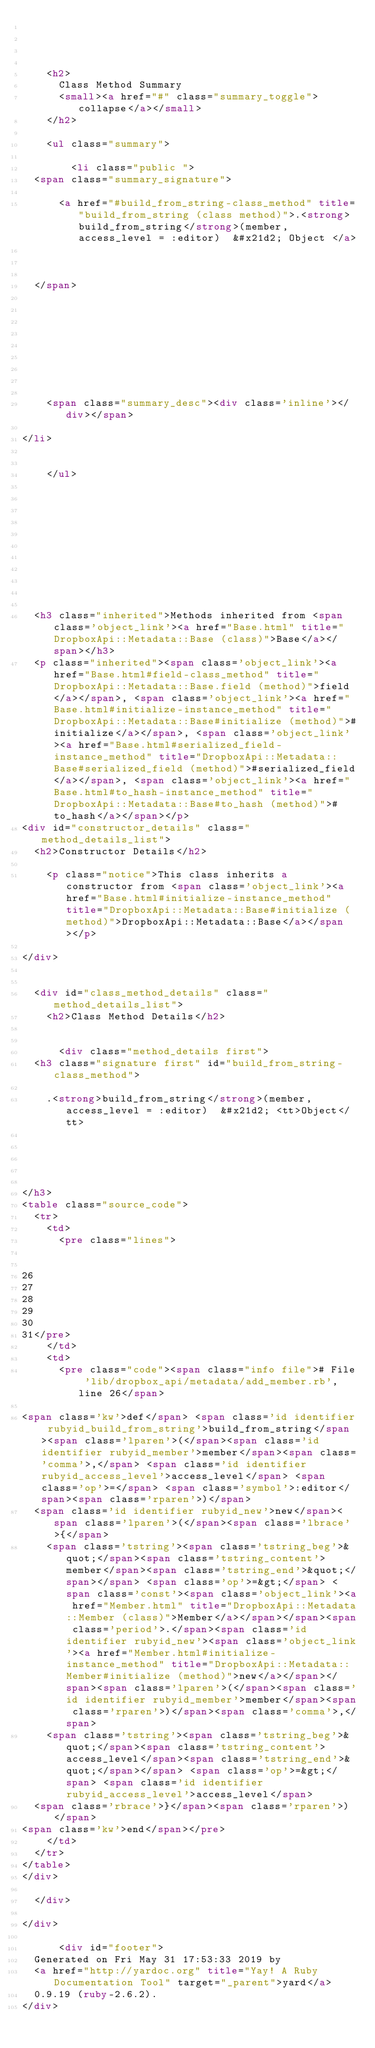Convert code to text. <code><loc_0><loc_0><loc_500><loc_500><_HTML_>


  
    <h2>
      Class Method Summary
      <small><a href="#" class="summary_toggle">collapse</a></small>
    </h2>

    <ul class="summary">
      
        <li class="public ">
  <span class="summary_signature">
    
      <a href="#build_from_string-class_method" title="build_from_string (class method)">.<strong>build_from_string</strong>(member, access_level = :editor)  &#x21d2; Object </a>
    

    
  </span>
  
  
  
  
  
  
  

  
    <span class="summary_desc"><div class='inline'></div></span>
  
</li>

      
    </ul>
  


  
  
  
  
  
  
  
  
  <h3 class="inherited">Methods inherited from <span class='object_link'><a href="Base.html" title="DropboxApi::Metadata::Base (class)">Base</a></span></h3>
  <p class="inherited"><span class='object_link'><a href="Base.html#field-class_method" title="DropboxApi::Metadata::Base.field (method)">field</a></span>, <span class='object_link'><a href="Base.html#initialize-instance_method" title="DropboxApi::Metadata::Base#initialize (method)">#initialize</a></span>, <span class='object_link'><a href="Base.html#serialized_field-instance_method" title="DropboxApi::Metadata::Base#serialized_field (method)">#serialized_field</a></span>, <span class='object_link'><a href="Base.html#to_hash-instance_method" title="DropboxApi::Metadata::Base#to_hash (method)">#to_hash</a></span></p>
<div id="constructor_details" class="method_details_list">
  <h2>Constructor Details</h2>
  
    <p class="notice">This class inherits a constructor from <span class='object_link'><a href="Base.html#initialize-instance_method" title="DropboxApi::Metadata::Base#initialize (method)">DropboxApi::Metadata::Base</a></span></p>
  
</div>


  <div id="class_method_details" class="method_details_list">
    <h2>Class Method Details</h2>

    
      <div class="method_details first">
  <h3 class="signature first" id="build_from_string-class_method">
  
    .<strong>build_from_string</strong>(member, access_level = :editor)  &#x21d2; <tt>Object</tt> 
  

  

  
</h3>
<table class="source_code">
  <tr>
    <td>
      <pre class="lines">


26
27
28
29
30
31</pre>
    </td>
    <td>
      <pre class="code"><span class="info file"># File 'lib/dropbox_api/metadata/add_member.rb', line 26</span>

<span class='kw'>def</span> <span class='id identifier rubyid_build_from_string'>build_from_string</span><span class='lparen'>(</span><span class='id identifier rubyid_member'>member</span><span class='comma'>,</span> <span class='id identifier rubyid_access_level'>access_level</span> <span class='op'>=</span> <span class='symbol'>:editor</span><span class='rparen'>)</span>
  <span class='id identifier rubyid_new'>new</span><span class='lparen'>(</span><span class='lbrace'>{</span>
    <span class='tstring'><span class='tstring_beg'>&quot;</span><span class='tstring_content'>member</span><span class='tstring_end'>&quot;</span></span> <span class='op'>=&gt;</span> <span class='const'><span class='object_link'><a href="Member.html" title="DropboxApi::Metadata::Member (class)">Member</a></span></span><span class='period'>.</span><span class='id identifier rubyid_new'><span class='object_link'><a href="Member.html#initialize-instance_method" title="DropboxApi::Metadata::Member#initialize (method)">new</a></span></span><span class='lparen'>(</span><span class='id identifier rubyid_member'>member</span><span class='rparen'>)</span><span class='comma'>,</span>
    <span class='tstring'><span class='tstring_beg'>&quot;</span><span class='tstring_content'>access_level</span><span class='tstring_end'>&quot;</span></span> <span class='op'>=&gt;</span> <span class='id identifier rubyid_access_level'>access_level</span>
  <span class='rbrace'>}</span><span class='rparen'>)</span>
<span class='kw'>end</span></pre>
    </td>
  </tr>
</table>
</div>
    
  </div>

</div>

      <div id="footer">
  Generated on Fri May 31 17:53:33 2019 by
  <a href="http://yardoc.org" title="Yay! A Ruby Documentation Tool" target="_parent">yard</a>
  0.9.19 (ruby-2.6.2).
</div>
</code> 